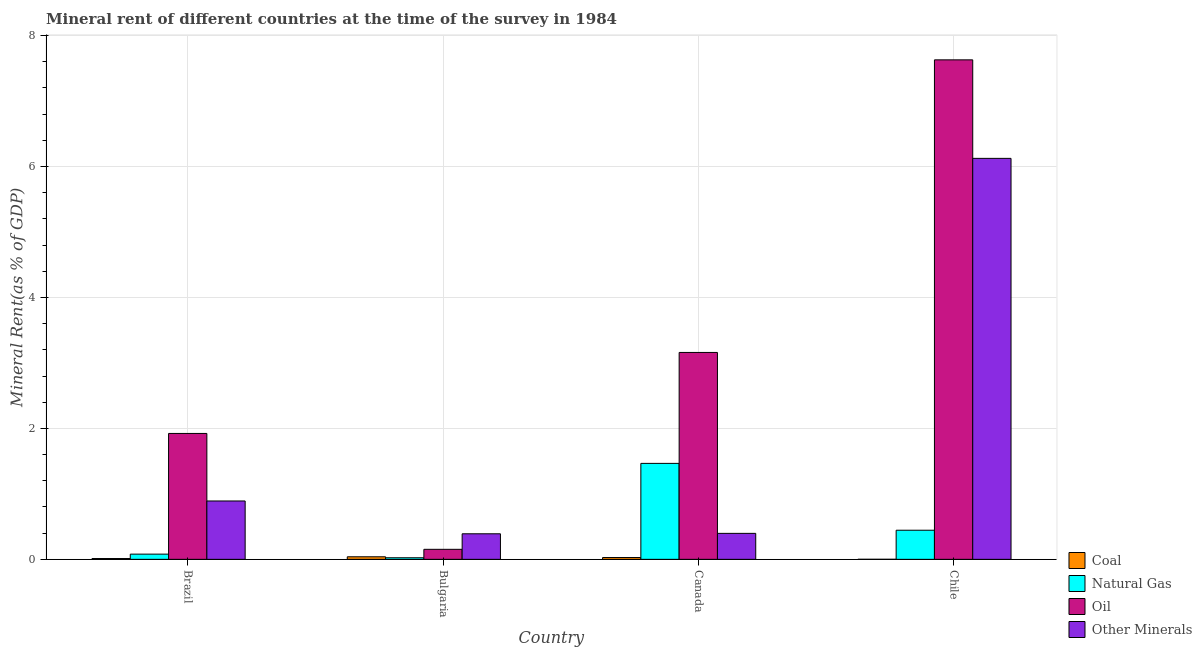How many groups of bars are there?
Keep it short and to the point. 4. Are the number of bars per tick equal to the number of legend labels?
Give a very brief answer. Yes. Are the number of bars on each tick of the X-axis equal?
Your answer should be compact. Yes. How many bars are there on the 2nd tick from the left?
Ensure brevity in your answer.  4. How many bars are there on the 1st tick from the right?
Your answer should be very brief. 4. What is the label of the 2nd group of bars from the left?
Provide a succinct answer. Bulgaria. In how many cases, is the number of bars for a given country not equal to the number of legend labels?
Keep it short and to the point. 0. What is the  rent of other minerals in Canada?
Give a very brief answer. 0.4. Across all countries, what is the maximum natural gas rent?
Your answer should be compact. 1.47. Across all countries, what is the minimum natural gas rent?
Keep it short and to the point. 0.02. In which country was the natural gas rent maximum?
Ensure brevity in your answer.  Canada. What is the total oil rent in the graph?
Provide a succinct answer. 12.87. What is the difference between the oil rent in Bulgaria and that in Chile?
Offer a terse response. -7.48. What is the difference between the  rent of other minerals in Bulgaria and the coal rent in Brazil?
Provide a succinct answer. 0.38. What is the average natural gas rent per country?
Ensure brevity in your answer.  0.5. What is the difference between the oil rent and  rent of other minerals in Bulgaria?
Keep it short and to the point. -0.24. What is the ratio of the oil rent in Canada to that in Chile?
Offer a terse response. 0.41. What is the difference between the highest and the second highest coal rent?
Provide a short and direct response. 0.01. What is the difference between the highest and the lowest  rent of other minerals?
Keep it short and to the point. 5.73. In how many countries, is the coal rent greater than the average coal rent taken over all countries?
Your answer should be very brief. 2. What does the 1st bar from the left in Chile represents?
Provide a succinct answer. Coal. What does the 3rd bar from the right in Brazil represents?
Provide a short and direct response. Natural Gas. Is it the case that in every country, the sum of the coal rent and natural gas rent is greater than the oil rent?
Your response must be concise. No. How many bars are there?
Your answer should be very brief. 16. What is the difference between two consecutive major ticks on the Y-axis?
Your answer should be compact. 2. Does the graph contain any zero values?
Provide a succinct answer. No. Where does the legend appear in the graph?
Offer a terse response. Bottom right. How are the legend labels stacked?
Provide a succinct answer. Vertical. What is the title of the graph?
Your answer should be very brief. Mineral rent of different countries at the time of the survey in 1984. What is the label or title of the Y-axis?
Provide a short and direct response. Mineral Rent(as % of GDP). What is the Mineral Rent(as % of GDP) of Coal in Brazil?
Provide a short and direct response. 0.01. What is the Mineral Rent(as % of GDP) of Natural Gas in Brazil?
Your response must be concise. 0.08. What is the Mineral Rent(as % of GDP) in Oil in Brazil?
Provide a succinct answer. 1.92. What is the Mineral Rent(as % of GDP) in Other Minerals in Brazil?
Provide a short and direct response. 0.89. What is the Mineral Rent(as % of GDP) in Coal in Bulgaria?
Your answer should be very brief. 0.04. What is the Mineral Rent(as % of GDP) in Natural Gas in Bulgaria?
Your answer should be very brief. 0.02. What is the Mineral Rent(as % of GDP) of Oil in Bulgaria?
Ensure brevity in your answer.  0.15. What is the Mineral Rent(as % of GDP) in Other Minerals in Bulgaria?
Your answer should be compact. 0.39. What is the Mineral Rent(as % of GDP) of Coal in Canada?
Your answer should be very brief. 0.03. What is the Mineral Rent(as % of GDP) of Natural Gas in Canada?
Your answer should be very brief. 1.47. What is the Mineral Rent(as % of GDP) of Oil in Canada?
Make the answer very short. 3.16. What is the Mineral Rent(as % of GDP) in Other Minerals in Canada?
Your answer should be compact. 0.4. What is the Mineral Rent(as % of GDP) of Coal in Chile?
Your answer should be very brief. 0. What is the Mineral Rent(as % of GDP) of Natural Gas in Chile?
Your answer should be very brief. 0.44. What is the Mineral Rent(as % of GDP) of Oil in Chile?
Provide a succinct answer. 7.63. What is the Mineral Rent(as % of GDP) of Other Minerals in Chile?
Keep it short and to the point. 6.12. Across all countries, what is the maximum Mineral Rent(as % of GDP) in Coal?
Provide a succinct answer. 0.04. Across all countries, what is the maximum Mineral Rent(as % of GDP) of Natural Gas?
Your answer should be very brief. 1.47. Across all countries, what is the maximum Mineral Rent(as % of GDP) in Oil?
Provide a short and direct response. 7.63. Across all countries, what is the maximum Mineral Rent(as % of GDP) in Other Minerals?
Offer a terse response. 6.12. Across all countries, what is the minimum Mineral Rent(as % of GDP) in Coal?
Provide a short and direct response. 0. Across all countries, what is the minimum Mineral Rent(as % of GDP) in Natural Gas?
Your response must be concise. 0.02. Across all countries, what is the minimum Mineral Rent(as % of GDP) in Oil?
Provide a succinct answer. 0.15. Across all countries, what is the minimum Mineral Rent(as % of GDP) in Other Minerals?
Give a very brief answer. 0.39. What is the total Mineral Rent(as % of GDP) of Coal in the graph?
Offer a very short reply. 0.08. What is the total Mineral Rent(as % of GDP) in Natural Gas in the graph?
Your answer should be compact. 2.01. What is the total Mineral Rent(as % of GDP) in Oil in the graph?
Give a very brief answer. 12.87. What is the total Mineral Rent(as % of GDP) in Other Minerals in the graph?
Offer a very short reply. 7.8. What is the difference between the Mineral Rent(as % of GDP) in Coal in Brazil and that in Bulgaria?
Make the answer very short. -0.03. What is the difference between the Mineral Rent(as % of GDP) of Natural Gas in Brazil and that in Bulgaria?
Make the answer very short. 0.06. What is the difference between the Mineral Rent(as % of GDP) of Oil in Brazil and that in Bulgaria?
Offer a very short reply. 1.77. What is the difference between the Mineral Rent(as % of GDP) of Other Minerals in Brazil and that in Bulgaria?
Offer a very short reply. 0.5. What is the difference between the Mineral Rent(as % of GDP) in Coal in Brazil and that in Canada?
Make the answer very short. -0.02. What is the difference between the Mineral Rent(as % of GDP) of Natural Gas in Brazil and that in Canada?
Provide a short and direct response. -1.39. What is the difference between the Mineral Rent(as % of GDP) in Oil in Brazil and that in Canada?
Keep it short and to the point. -1.24. What is the difference between the Mineral Rent(as % of GDP) in Other Minerals in Brazil and that in Canada?
Make the answer very short. 0.49. What is the difference between the Mineral Rent(as % of GDP) in Coal in Brazil and that in Chile?
Offer a very short reply. 0.01. What is the difference between the Mineral Rent(as % of GDP) in Natural Gas in Brazil and that in Chile?
Keep it short and to the point. -0.37. What is the difference between the Mineral Rent(as % of GDP) of Oil in Brazil and that in Chile?
Ensure brevity in your answer.  -5.71. What is the difference between the Mineral Rent(as % of GDP) in Other Minerals in Brazil and that in Chile?
Your answer should be very brief. -5.23. What is the difference between the Mineral Rent(as % of GDP) in Coal in Bulgaria and that in Canada?
Provide a succinct answer. 0.01. What is the difference between the Mineral Rent(as % of GDP) of Natural Gas in Bulgaria and that in Canada?
Offer a very short reply. -1.44. What is the difference between the Mineral Rent(as % of GDP) of Oil in Bulgaria and that in Canada?
Your response must be concise. -3.01. What is the difference between the Mineral Rent(as % of GDP) in Other Minerals in Bulgaria and that in Canada?
Provide a short and direct response. -0.01. What is the difference between the Mineral Rent(as % of GDP) in Coal in Bulgaria and that in Chile?
Keep it short and to the point. 0.04. What is the difference between the Mineral Rent(as % of GDP) of Natural Gas in Bulgaria and that in Chile?
Provide a short and direct response. -0.42. What is the difference between the Mineral Rent(as % of GDP) of Oil in Bulgaria and that in Chile?
Your response must be concise. -7.48. What is the difference between the Mineral Rent(as % of GDP) of Other Minerals in Bulgaria and that in Chile?
Keep it short and to the point. -5.73. What is the difference between the Mineral Rent(as % of GDP) in Coal in Canada and that in Chile?
Provide a short and direct response. 0.03. What is the difference between the Mineral Rent(as % of GDP) in Oil in Canada and that in Chile?
Ensure brevity in your answer.  -4.47. What is the difference between the Mineral Rent(as % of GDP) of Other Minerals in Canada and that in Chile?
Your response must be concise. -5.73. What is the difference between the Mineral Rent(as % of GDP) of Coal in Brazil and the Mineral Rent(as % of GDP) of Natural Gas in Bulgaria?
Provide a succinct answer. -0.01. What is the difference between the Mineral Rent(as % of GDP) in Coal in Brazil and the Mineral Rent(as % of GDP) in Oil in Bulgaria?
Make the answer very short. -0.14. What is the difference between the Mineral Rent(as % of GDP) in Coal in Brazil and the Mineral Rent(as % of GDP) in Other Minerals in Bulgaria?
Give a very brief answer. -0.38. What is the difference between the Mineral Rent(as % of GDP) in Natural Gas in Brazil and the Mineral Rent(as % of GDP) in Oil in Bulgaria?
Your response must be concise. -0.07. What is the difference between the Mineral Rent(as % of GDP) of Natural Gas in Brazil and the Mineral Rent(as % of GDP) of Other Minerals in Bulgaria?
Offer a terse response. -0.31. What is the difference between the Mineral Rent(as % of GDP) of Oil in Brazil and the Mineral Rent(as % of GDP) of Other Minerals in Bulgaria?
Provide a short and direct response. 1.53. What is the difference between the Mineral Rent(as % of GDP) of Coal in Brazil and the Mineral Rent(as % of GDP) of Natural Gas in Canada?
Your answer should be compact. -1.45. What is the difference between the Mineral Rent(as % of GDP) of Coal in Brazil and the Mineral Rent(as % of GDP) of Oil in Canada?
Your response must be concise. -3.15. What is the difference between the Mineral Rent(as % of GDP) of Coal in Brazil and the Mineral Rent(as % of GDP) of Other Minerals in Canada?
Keep it short and to the point. -0.38. What is the difference between the Mineral Rent(as % of GDP) in Natural Gas in Brazil and the Mineral Rent(as % of GDP) in Oil in Canada?
Offer a terse response. -3.08. What is the difference between the Mineral Rent(as % of GDP) of Natural Gas in Brazil and the Mineral Rent(as % of GDP) of Other Minerals in Canada?
Keep it short and to the point. -0.32. What is the difference between the Mineral Rent(as % of GDP) of Oil in Brazil and the Mineral Rent(as % of GDP) of Other Minerals in Canada?
Your answer should be compact. 1.53. What is the difference between the Mineral Rent(as % of GDP) in Coal in Brazil and the Mineral Rent(as % of GDP) in Natural Gas in Chile?
Make the answer very short. -0.43. What is the difference between the Mineral Rent(as % of GDP) of Coal in Brazil and the Mineral Rent(as % of GDP) of Oil in Chile?
Your response must be concise. -7.62. What is the difference between the Mineral Rent(as % of GDP) of Coal in Brazil and the Mineral Rent(as % of GDP) of Other Minerals in Chile?
Provide a short and direct response. -6.11. What is the difference between the Mineral Rent(as % of GDP) in Natural Gas in Brazil and the Mineral Rent(as % of GDP) in Oil in Chile?
Ensure brevity in your answer.  -7.55. What is the difference between the Mineral Rent(as % of GDP) of Natural Gas in Brazil and the Mineral Rent(as % of GDP) of Other Minerals in Chile?
Provide a short and direct response. -6.05. What is the difference between the Mineral Rent(as % of GDP) of Oil in Brazil and the Mineral Rent(as % of GDP) of Other Minerals in Chile?
Provide a succinct answer. -4.2. What is the difference between the Mineral Rent(as % of GDP) in Coal in Bulgaria and the Mineral Rent(as % of GDP) in Natural Gas in Canada?
Ensure brevity in your answer.  -1.43. What is the difference between the Mineral Rent(as % of GDP) of Coal in Bulgaria and the Mineral Rent(as % of GDP) of Oil in Canada?
Your response must be concise. -3.12. What is the difference between the Mineral Rent(as % of GDP) in Coal in Bulgaria and the Mineral Rent(as % of GDP) in Other Minerals in Canada?
Provide a short and direct response. -0.36. What is the difference between the Mineral Rent(as % of GDP) in Natural Gas in Bulgaria and the Mineral Rent(as % of GDP) in Oil in Canada?
Ensure brevity in your answer.  -3.14. What is the difference between the Mineral Rent(as % of GDP) in Natural Gas in Bulgaria and the Mineral Rent(as % of GDP) in Other Minerals in Canada?
Provide a short and direct response. -0.37. What is the difference between the Mineral Rent(as % of GDP) in Oil in Bulgaria and the Mineral Rent(as % of GDP) in Other Minerals in Canada?
Offer a terse response. -0.24. What is the difference between the Mineral Rent(as % of GDP) of Coal in Bulgaria and the Mineral Rent(as % of GDP) of Natural Gas in Chile?
Give a very brief answer. -0.41. What is the difference between the Mineral Rent(as % of GDP) of Coal in Bulgaria and the Mineral Rent(as % of GDP) of Oil in Chile?
Your answer should be very brief. -7.59. What is the difference between the Mineral Rent(as % of GDP) of Coal in Bulgaria and the Mineral Rent(as % of GDP) of Other Minerals in Chile?
Give a very brief answer. -6.09. What is the difference between the Mineral Rent(as % of GDP) in Natural Gas in Bulgaria and the Mineral Rent(as % of GDP) in Oil in Chile?
Offer a terse response. -7.61. What is the difference between the Mineral Rent(as % of GDP) of Natural Gas in Bulgaria and the Mineral Rent(as % of GDP) of Other Minerals in Chile?
Keep it short and to the point. -6.1. What is the difference between the Mineral Rent(as % of GDP) in Oil in Bulgaria and the Mineral Rent(as % of GDP) in Other Minerals in Chile?
Make the answer very short. -5.97. What is the difference between the Mineral Rent(as % of GDP) in Coal in Canada and the Mineral Rent(as % of GDP) in Natural Gas in Chile?
Make the answer very short. -0.42. What is the difference between the Mineral Rent(as % of GDP) of Coal in Canada and the Mineral Rent(as % of GDP) of Oil in Chile?
Offer a very short reply. -7.6. What is the difference between the Mineral Rent(as % of GDP) in Coal in Canada and the Mineral Rent(as % of GDP) in Other Minerals in Chile?
Give a very brief answer. -6.1. What is the difference between the Mineral Rent(as % of GDP) of Natural Gas in Canada and the Mineral Rent(as % of GDP) of Oil in Chile?
Provide a succinct answer. -6.16. What is the difference between the Mineral Rent(as % of GDP) of Natural Gas in Canada and the Mineral Rent(as % of GDP) of Other Minerals in Chile?
Give a very brief answer. -4.66. What is the difference between the Mineral Rent(as % of GDP) of Oil in Canada and the Mineral Rent(as % of GDP) of Other Minerals in Chile?
Provide a succinct answer. -2.96. What is the average Mineral Rent(as % of GDP) in Coal per country?
Provide a short and direct response. 0.02. What is the average Mineral Rent(as % of GDP) in Natural Gas per country?
Make the answer very short. 0.5. What is the average Mineral Rent(as % of GDP) in Oil per country?
Your answer should be compact. 3.22. What is the average Mineral Rent(as % of GDP) of Other Minerals per country?
Offer a very short reply. 1.95. What is the difference between the Mineral Rent(as % of GDP) in Coal and Mineral Rent(as % of GDP) in Natural Gas in Brazil?
Keep it short and to the point. -0.07. What is the difference between the Mineral Rent(as % of GDP) of Coal and Mineral Rent(as % of GDP) of Oil in Brazil?
Your answer should be compact. -1.91. What is the difference between the Mineral Rent(as % of GDP) of Coal and Mineral Rent(as % of GDP) of Other Minerals in Brazil?
Ensure brevity in your answer.  -0.88. What is the difference between the Mineral Rent(as % of GDP) of Natural Gas and Mineral Rent(as % of GDP) of Oil in Brazil?
Offer a terse response. -1.84. What is the difference between the Mineral Rent(as % of GDP) in Natural Gas and Mineral Rent(as % of GDP) in Other Minerals in Brazil?
Ensure brevity in your answer.  -0.81. What is the difference between the Mineral Rent(as % of GDP) in Oil and Mineral Rent(as % of GDP) in Other Minerals in Brazil?
Keep it short and to the point. 1.03. What is the difference between the Mineral Rent(as % of GDP) in Coal and Mineral Rent(as % of GDP) in Natural Gas in Bulgaria?
Provide a short and direct response. 0.01. What is the difference between the Mineral Rent(as % of GDP) in Coal and Mineral Rent(as % of GDP) in Oil in Bulgaria?
Make the answer very short. -0.11. What is the difference between the Mineral Rent(as % of GDP) of Coal and Mineral Rent(as % of GDP) of Other Minerals in Bulgaria?
Keep it short and to the point. -0.35. What is the difference between the Mineral Rent(as % of GDP) in Natural Gas and Mineral Rent(as % of GDP) in Oil in Bulgaria?
Provide a short and direct response. -0.13. What is the difference between the Mineral Rent(as % of GDP) in Natural Gas and Mineral Rent(as % of GDP) in Other Minerals in Bulgaria?
Offer a terse response. -0.37. What is the difference between the Mineral Rent(as % of GDP) of Oil and Mineral Rent(as % of GDP) of Other Minerals in Bulgaria?
Give a very brief answer. -0.24. What is the difference between the Mineral Rent(as % of GDP) of Coal and Mineral Rent(as % of GDP) of Natural Gas in Canada?
Give a very brief answer. -1.44. What is the difference between the Mineral Rent(as % of GDP) in Coal and Mineral Rent(as % of GDP) in Oil in Canada?
Ensure brevity in your answer.  -3.13. What is the difference between the Mineral Rent(as % of GDP) of Coal and Mineral Rent(as % of GDP) of Other Minerals in Canada?
Your answer should be compact. -0.37. What is the difference between the Mineral Rent(as % of GDP) in Natural Gas and Mineral Rent(as % of GDP) in Oil in Canada?
Keep it short and to the point. -1.69. What is the difference between the Mineral Rent(as % of GDP) in Natural Gas and Mineral Rent(as % of GDP) in Other Minerals in Canada?
Your answer should be very brief. 1.07. What is the difference between the Mineral Rent(as % of GDP) of Oil and Mineral Rent(as % of GDP) of Other Minerals in Canada?
Offer a very short reply. 2.76. What is the difference between the Mineral Rent(as % of GDP) of Coal and Mineral Rent(as % of GDP) of Natural Gas in Chile?
Provide a short and direct response. -0.44. What is the difference between the Mineral Rent(as % of GDP) of Coal and Mineral Rent(as % of GDP) of Oil in Chile?
Ensure brevity in your answer.  -7.63. What is the difference between the Mineral Rent(as % of GDP) in Coal and Mineral Rent(as % of GDP) in Other Minerals in Chile?
Ensure brevity in your answer.  -6.12. What is the difference between the Mineral Rent(as % of GDP) in Natural Gas and Mineral Rent(as % of GDP) in Oil in Chile?
Your response must be concise. -7.18. What is the difference between the Mineral Rent(as % of GDP) in Natural Gas and Mineral Rent(as % of GDP) in Other Minerals in Chile?
Offer a terse response. -5.68. What is the difference between the Mineral Rent(as % of GDP) in Oil and Mineral Rent(as % of GDP) in Other Minerals in Chile?
Your response must be concise. 1.5. What is the ratio of the Mineral Rent(as % of GDP) of Coal in Brazil to that in Bulgaria?
Give a very brief answer. 0.32. What is the ratio of the Mineral Rent(as % of GDP) in Natural Gas in Brazil to that in Bulgaria?
Your response must be concise. 3.3. What is the ratio of the Mineral Rent(as % of GDP) of Oil in Brazil to that in Bulgaria?
Your answer should be very brief. 12.57. What is the ratio of the Mineral Rent(as % of GDP) of Other Minerals in Brazil to that in Bulgaria?
Offer a terse response. 2.29. What is the ratio of the Mineral Rent(as % of GDP) of Coal in Brazil to that in Canada?
Offer a very short reply. 0.45. What is the ratio of the Mineral Rent(as % of GDP) of Natural Gas in Brazil to that in Canada?
Give a very brief answer. 0.05. What is the ratio of the Mineral Rent(as % of GDP) of Oil in Brazil to that in Canada?
Ensure brevity in your answer.  0.61. What is the ratio of the Mineral Rent(as % of GDP) in Other Minerals in Brazil to that in Canada?
Give a very brief answer. 2.25. What is the ratio of the Mineral Rent(as % of GDP) in Coal in Brazil to that in Chile?
Keep it short and to the point. 32.93. What is the ratio of the Mineral Rent(as % of GDP) in Natural Gas in Brazil to that in Chile?
Keep it short and to the point. 0.18. What is the ratio of the Mineral Rent(as % of GDP) of Oil in Brazil to that in Chile?
Your response must be concise. 0.25. What is the ratio of the Mineral Rent(as % of GDP) of Other Minerals in Brazil to that in Chile?
Your answer should be very brief. 0.15. What is the ratio of the Mineral Rent(as % of GDP) in Coal in Bulgaria to that in Canada?
Make the answer very short. 1.41. What is the ratio of the Mineral Rent(as % of GDP) in Natural Gas in Bulgaria to that in Canada?
Your response must be concise. 0.02. What is the ratio of the Mineral Rent(as % of GDP) in Oil in Bulgaria to that in Canada?
Provide a succinct answer. 0.05. What is the ratio of the Mineral Rent(as % of GDP) of Other Minerals in Bulgaria to that in Canada?
Your answer should be compact. 0.98. What is the ratio of the Mineral Rent(as % of GDP) of Coal in Bulgaria to that in Chile?
Make the answer very short. 103.58. What is the ratio of the Mineral Rent(as % of GDP) of Natural Gas in Bulgaria to that in Chile?
Provide a short and direct response. 0.05. What is the ratio of the Mineral Rent(as % of GDP) in Other Minerals in Bulgaria to that in Chile?
Offer a terse response. 0.06. What is the ratio of the Mineral Rent(as % of GDP) in Coal in Canada to that in Chile?
Offer a terse response. 73.66. What is the ratio of the Mineral Rent(as % of GDP) of Natural Gas in Canada to that in Chile?
Give a very brief answer. 3.3. What is the ratio of the Mineral Rent(as % of GDP) of Oil in Canada to that in Chile?
Provide a succinct answer. 0.41. What is the ratio of the Mineral Rent(as % of GDP) in Other Minerals in Canada to that in Chile?
Your answer should be compact. 0.06. What is the difference between the highest and the second highest Mineral Rent(as % of GDP) of Coal?
Provide a succinct answer. 0.01. What is the difference between the highest and the second highest Mineral Rent(as % of GDP) in Natural Gas?
Your answer should be compact. 1.02. What is the difference between the highest and the second highest Mineral Rent(as % of GDP) in Oil?
Offer a very short reply. 4.47. What is the difference between the highest and the second highest Mineral Rent(as % of GDP) of Other Minerals?
Keep it short and to the point. 5.23. What is the difference between the highest and the lowest Mineral Rent(as % of GDP) of Coal?
Provide a short and direct response. 0.04. What is the difference between the highest and the lowest Mineral Rent(as % of GDP) of Natural Gas?
Your answer should be very brief. 1.44. What is the difference between the highest and the lowest Mineral Rent(as % of GDP) of Oil?
Ensure brevity in your answer.  7.48. What is the difference between the highest and the lowest Mineral Rent(as % of GDP) of Other Minerals?
Your answer should be compact. 5.73. 